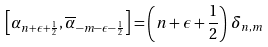Convert formula to latex. <formula><loc_0><loc_0><loc_500><loc_500>\left [ \alpha _ { n + \epsilon + \frac { 1 } { 2 } } , \overline { \alpha } _ { - m - \epsilon - \frac { 1 } { 2 } } \right ] = \left ( n + \epsilon + \frac { 1 } { 2 } \right ) \, \delta _ { n , m }</formula> 